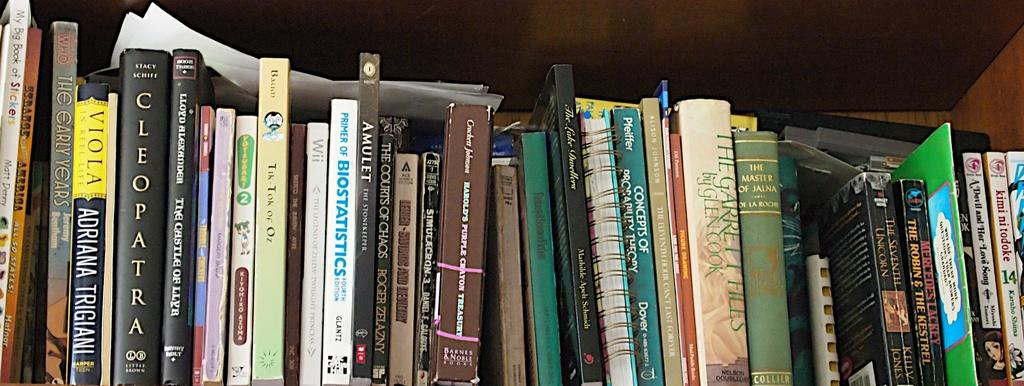<image>
Share a concise interpretation of the image provided. A collection of books side by side and one being titled Cleopatra. 